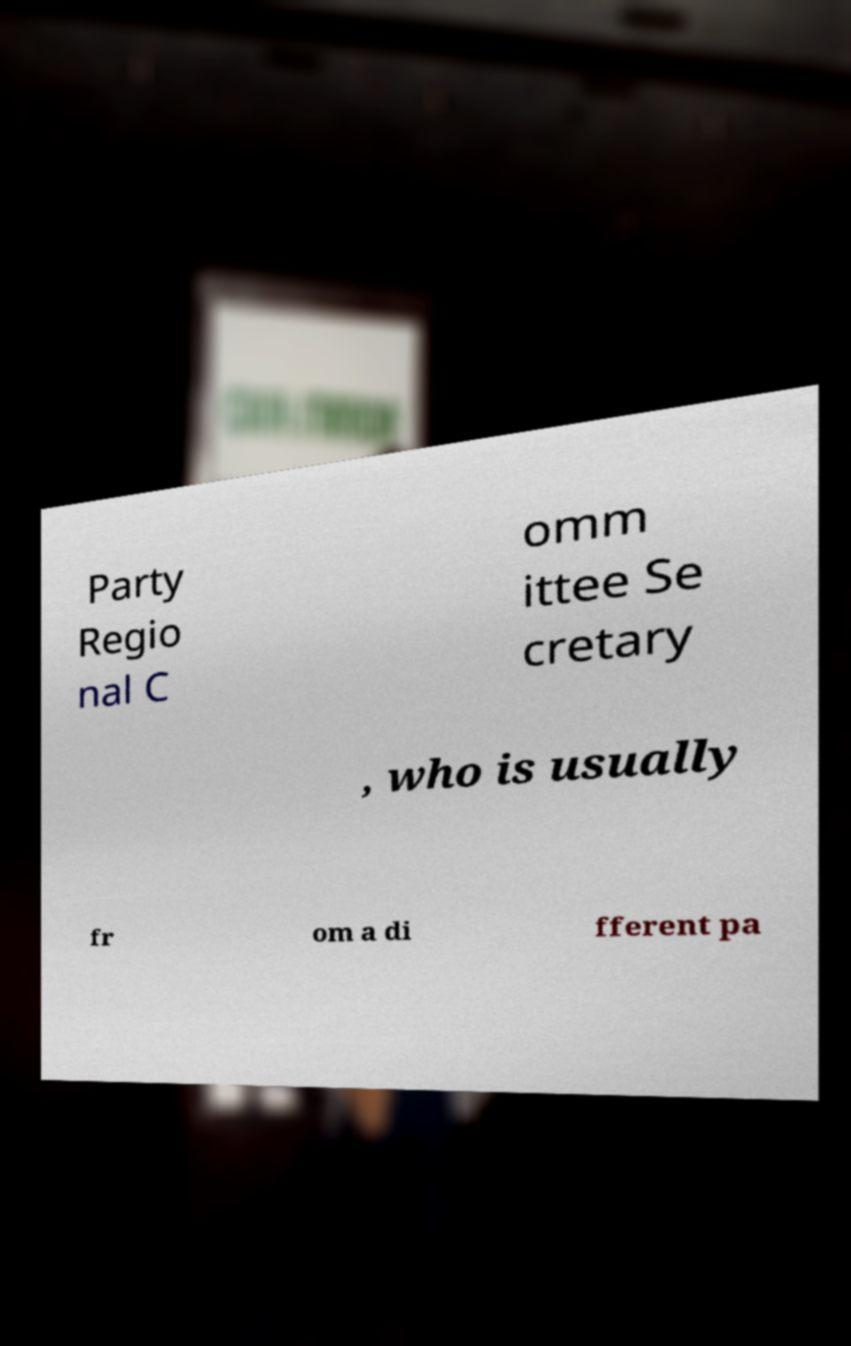Could you extract and type out the text from this image? Party Regio nal C omm ittee Se cretary , who is usually fr om a di fferent pa 